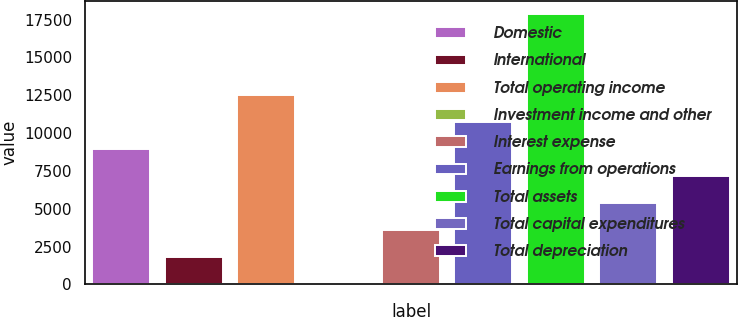<chart> <loc_0><loc_0><loc_500><loc_500><bar_chart><fcel>Domestic<fcel>International<fcel>Total operating income<fcel>Investment income and other<fcel>Interest expense<fcel>Earnings from operations<fcel>Total assets<fcel>Total capital expenditures<fcel>Total depreciation<nl><fcel>8950<fcel>1830.8<fcel>12509.6<fcel>51<fcel>3610.6<fcel>10729.8<fcel>17849<fcel>5390.4<fcel>7170.2<nl></chart> 